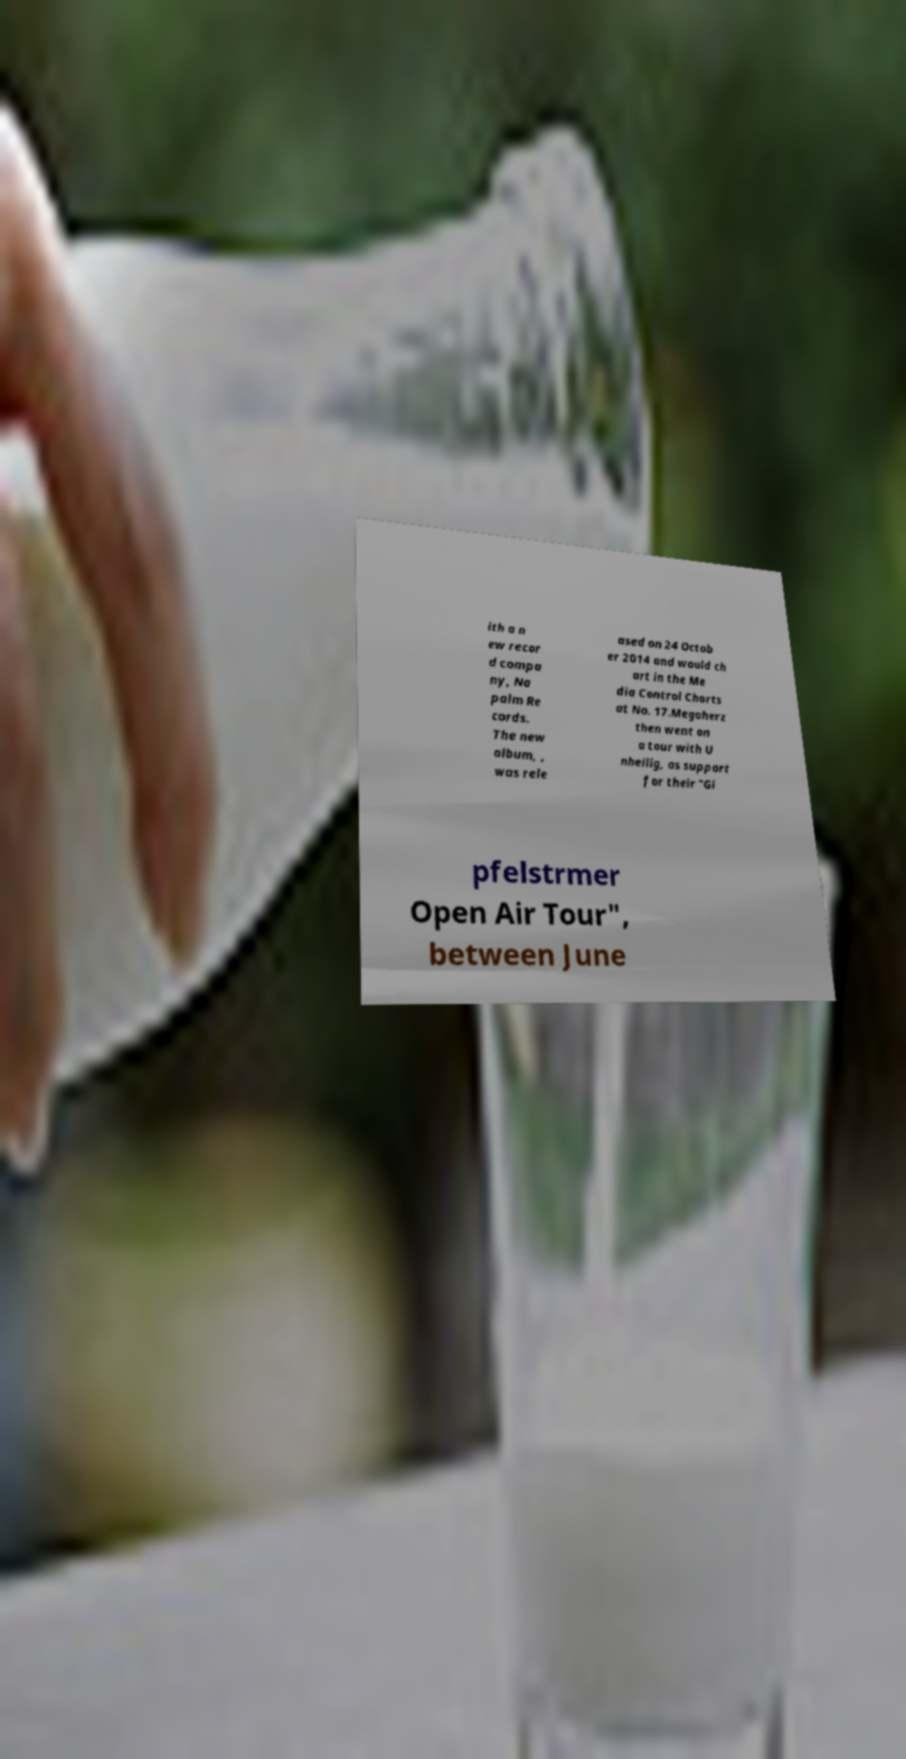Please identify and transcribe the text found in this image. ith a n ew recor d compa ny, Na palm Re cords. The new album, , was rele ased on 24 Octob er 2014 and would ch art in the Me dia Control Charts at No. 17.Megaherz then went on a tour with U nheilig, as support for their "Gi pfelstrmer Open Air Tour", between June 